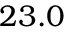Convert formula to latex. <formula><loc_0><loc_0><loc_500><loc_500>2 3 . 0</formula> 